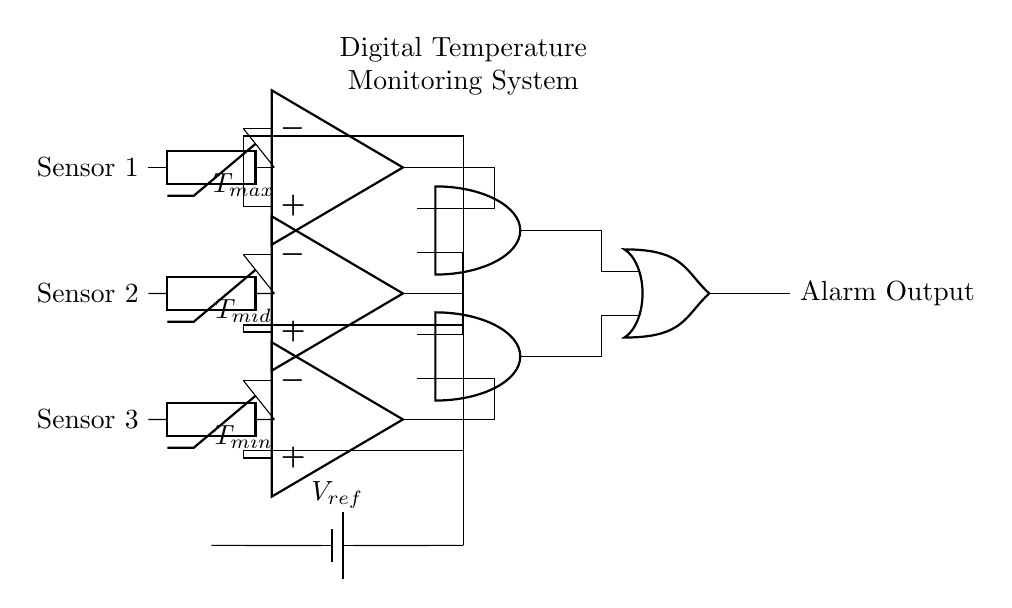What type of components are used for temperature sensing? The components used for temperature sensing in the circuit are thermistors, which are positioned as Sensor 1, Sensor 2, and Sensor 3.
Answer: thermistors What is the function of the operational amplifiers in this circuit? The operational amplifiers function as comparators to compare the voltage from the temperature sensors against reference voltages to determine if the temperature exceeds set thresholds.
Answer: comparators How many AND gates are shown in this circuit? There are two AND gates present in the circuit, labeled as and1 and and2.
Answer: two What is the role of the reference voltage in this circuit? The reference voltage is used as a baseline to compare the output of each thermistor through the respective operational amplifiers to decide if an alarm should be triggered.
Answer: baseline comparison What is the output of the OR gate? The output of the OR gate is an alarm output, which indicates if the conditions from the AND gates signal a need for an alert regarding temperature levels.
Answer: Alarm Output What are the threshold reference voltages labeled in the circuit? The threshold reference voltages labeled in the circuit are T_max, T_mid, and T_min, corresponding to the maximum, mid-range, and minimum acceptable temperature thresholds for the vaccines.
Answer: T_max, T_mid, T_min How does the circuit determine when to activate the alarm? The circuit activates the alarm when either of the AND gates produces a high output, which occurs only when both inputs to an AND gate are high, implying that a temperature condition has been met.
Answer: high output from AND gates 